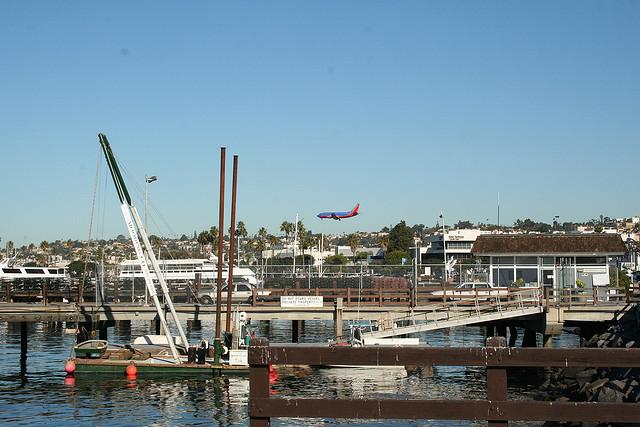What is soaring through the air? plane 